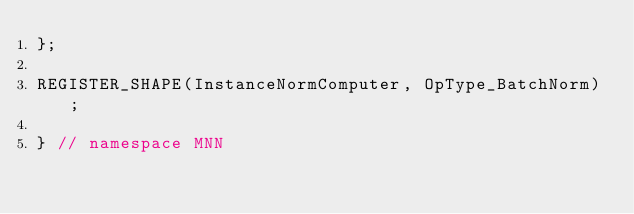Convert code to text. <code><loc_0><loc_0><loc_500><loc_500><_C++_>};

REGISTER_SHAPE(InstanceNormComputer, OpType_BatchNorm);

} // namespace MNN
</code> 